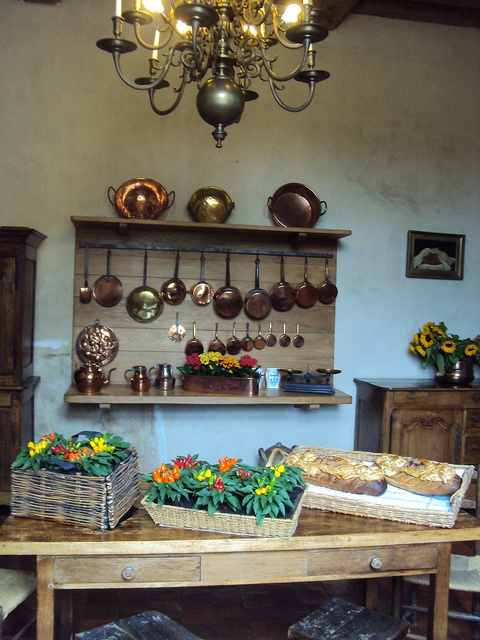Describe the objects in this image and their specific colors. I can see potted plant in gray, turquoise, black, teal, and darkgray tones, potted plant in gray, darkgray, black, and teal tones, vase in gray, darkgray, and black tones, potted plant in gray, black, olive, and darkgreen tones, and potted plant in gray, black, maroon, and brown tones in this image. 